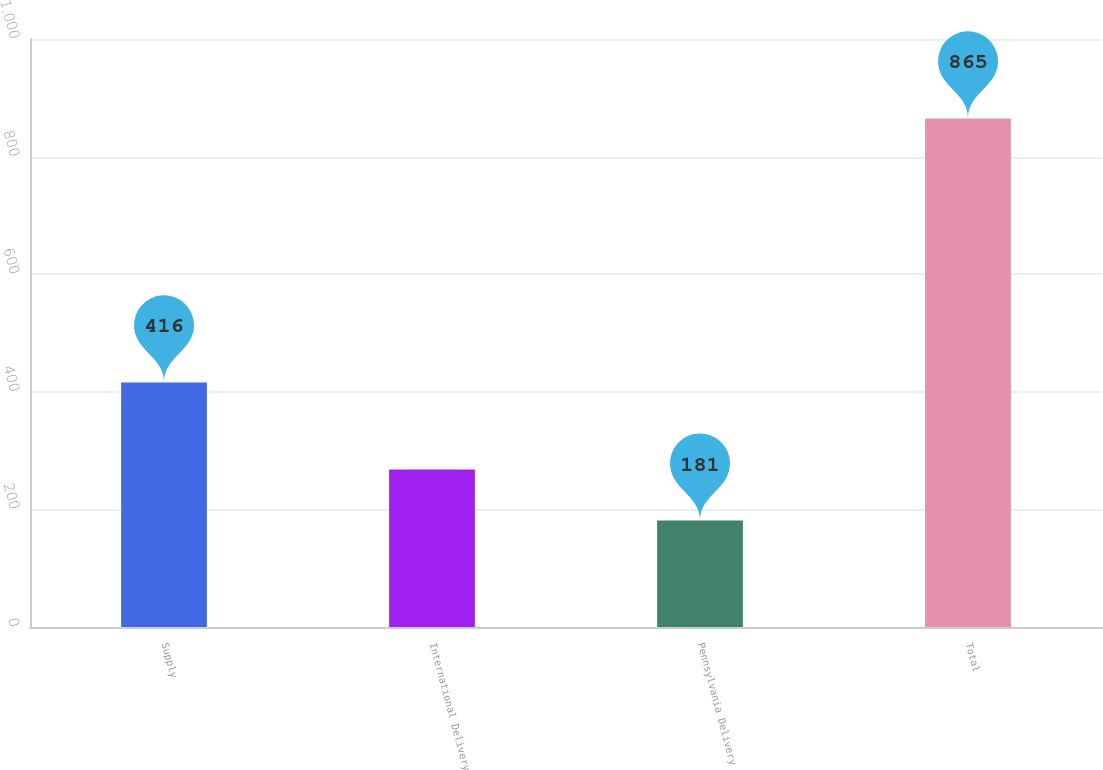Convert chart. <chart><loc_0><loc_0><loc_500><loc_500><bar_chart><fcel>Supply<fcel>International Delivery<fcel>Pennsylvania Delivery<fcel>Total<nl><fcel>416<fcel>268<fcel>181<fcel>865<nl></chart> 